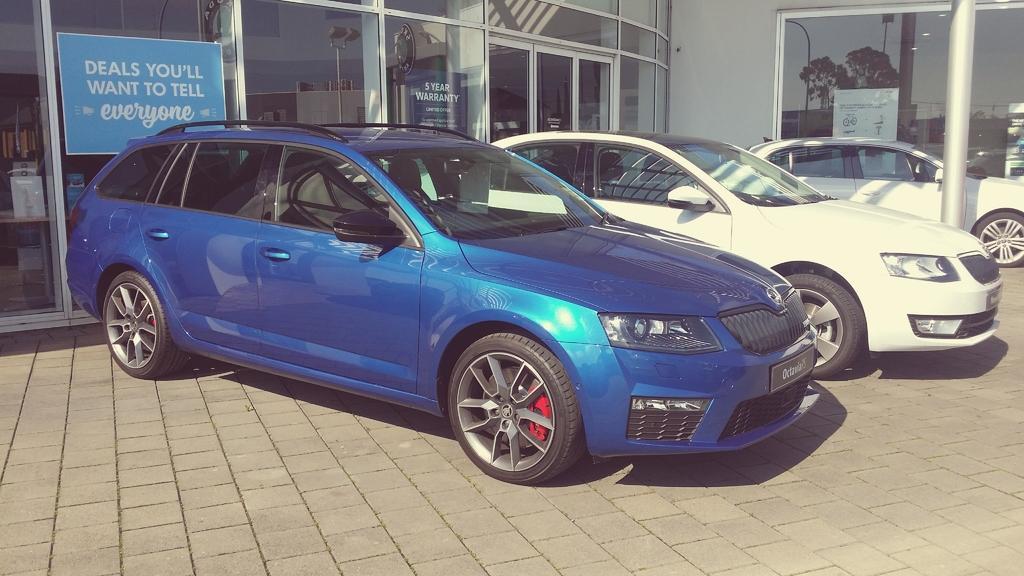Could you give a brief overview of what you see in this image? This picture is clicked outside. In the center we can see the cars parked on the pavement. In the background we can see the wall, text on the banners and we can see the wall of the building and we can see the reflection of the sky and the reflection of trees and some other objects on the glass and we can see many other objects. 